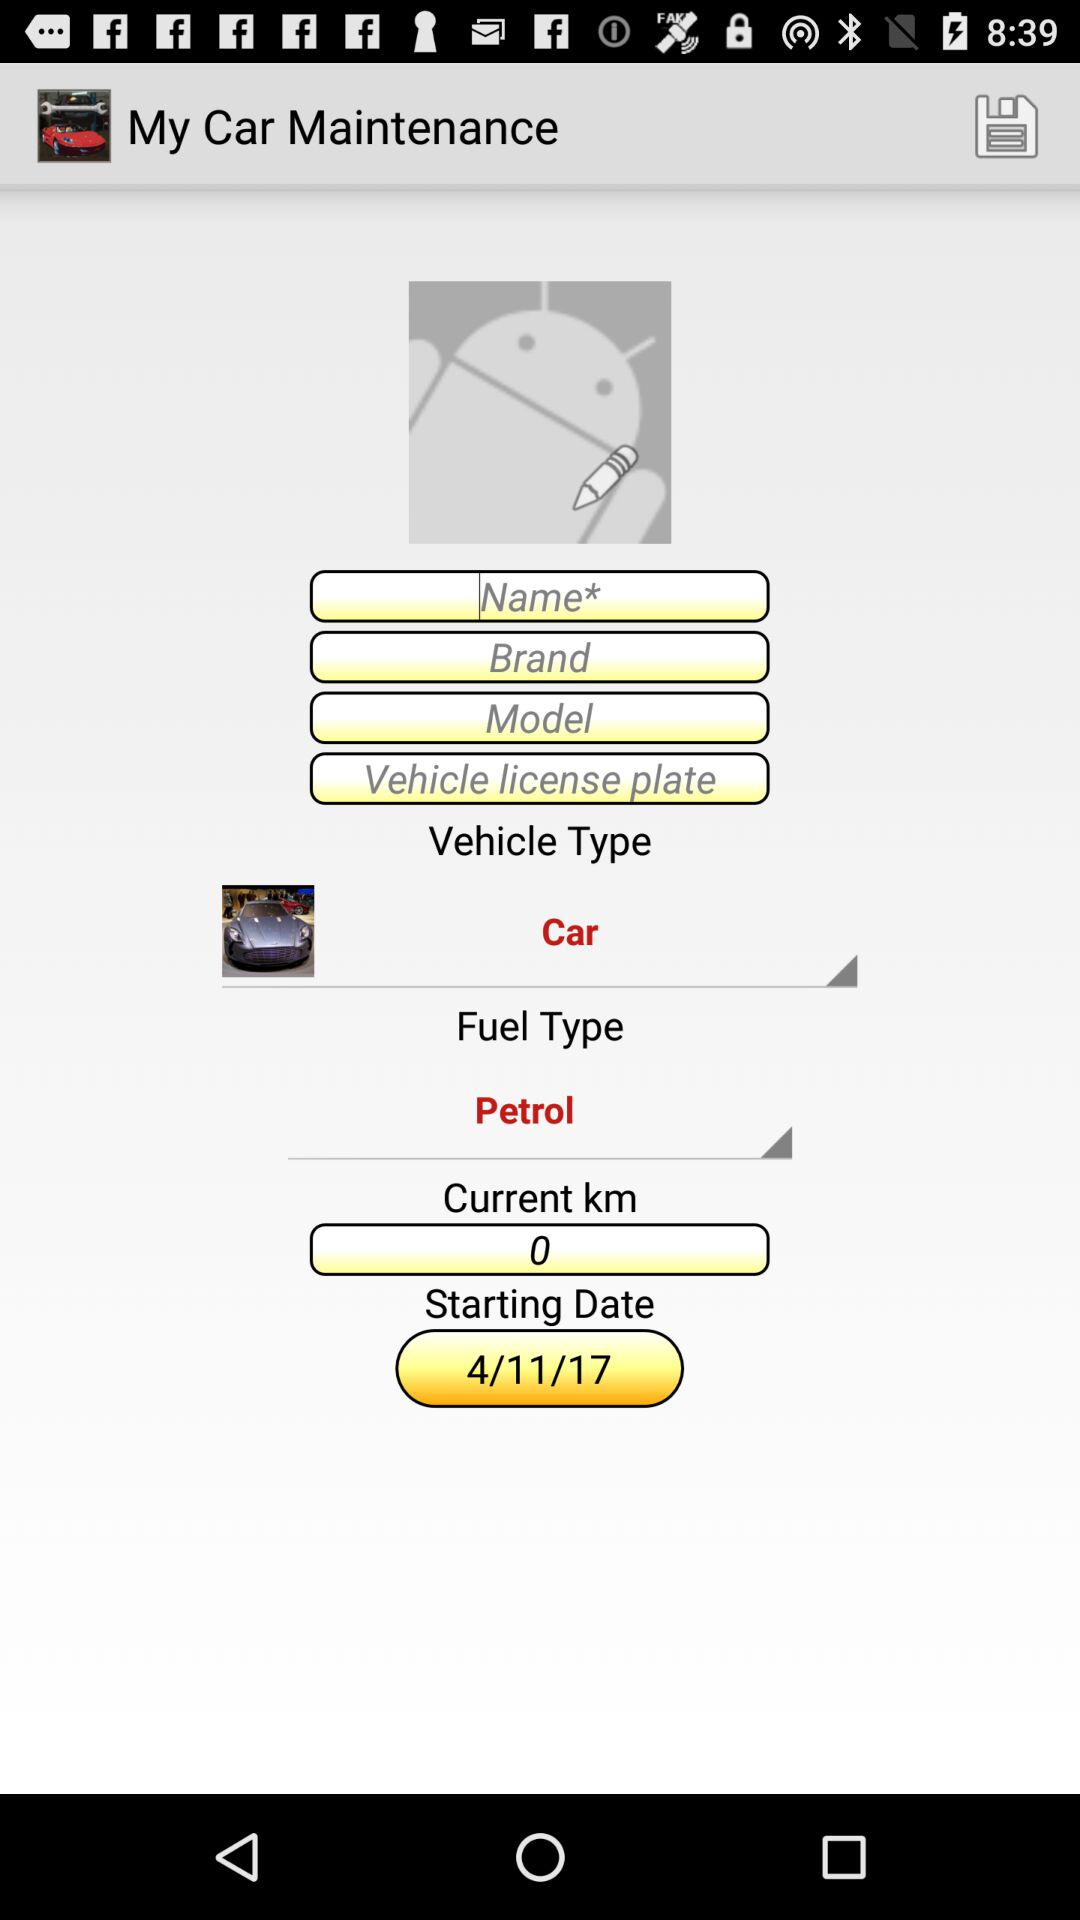What is the "Current km"? The "Current km" is 0. 